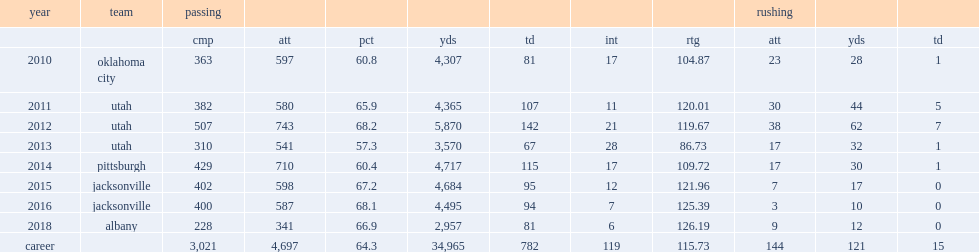How many touchdown passes did tommy grady have in 2012? 142.0. 